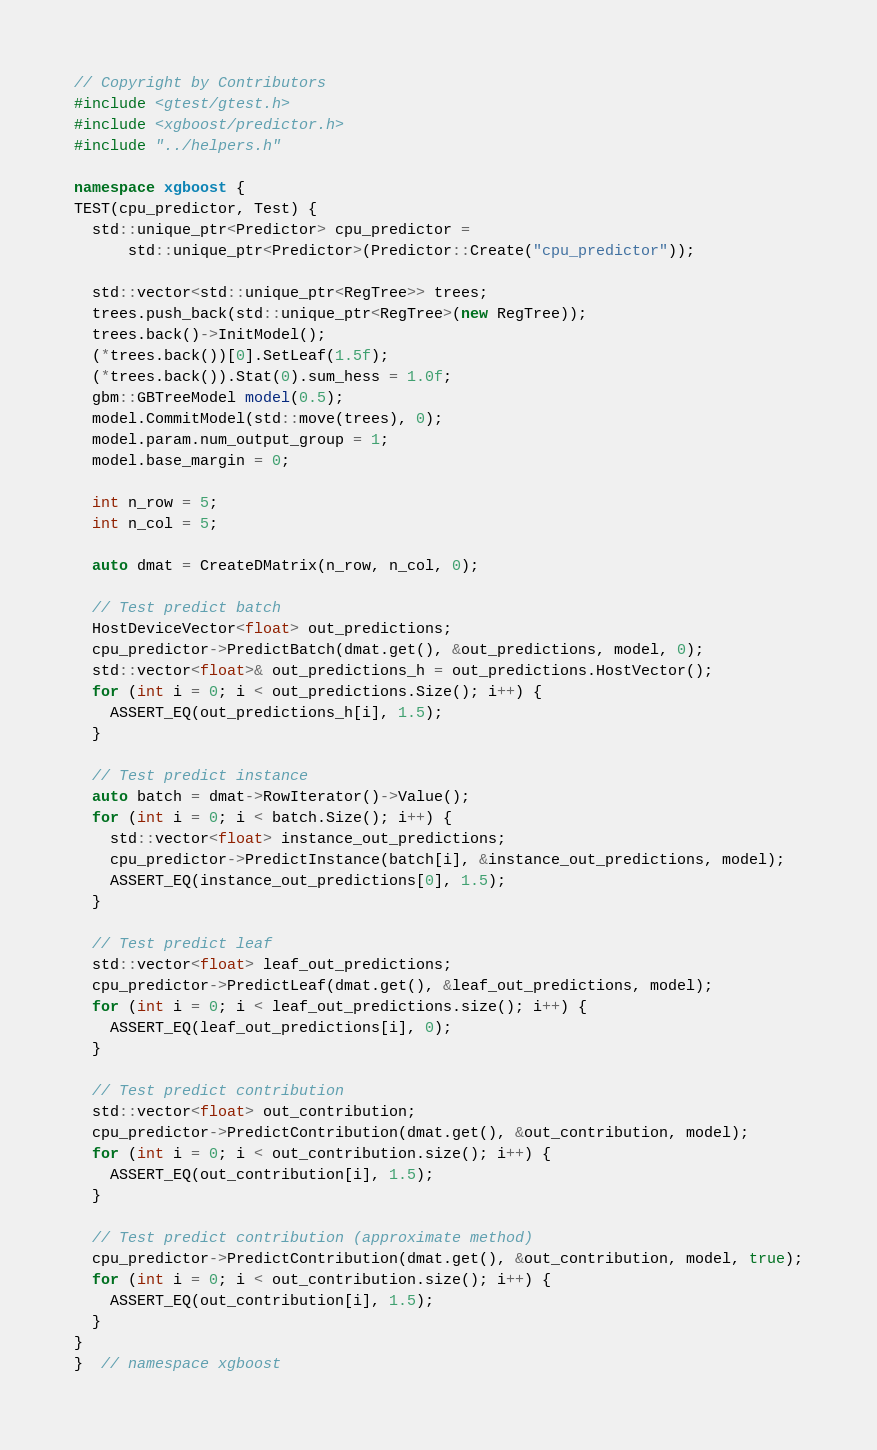<code> <loc_0><loc_0><loc_500><loc_500><_C++_>// Copyright by Contributors
#include <gtest/gtest.h>
#include <xgboost/predictor.h>
#include "../helpers.h"

namespace xgboost {
TEST(cpu_predictor, Test) {
  std::unique_ptr<Predictor> cpu_predictor =
      std::unique_ptr<Predictor>(Predictor::Create("cpu_predictor"));

  std::vector<std::unique_ptr<RegTree>> trees;
  trees.push_back(std::unique_ptr<RegTree>(new RegTree));
  trees.back()->InitModel();
  (*trees.back())[0].SetLeaf(1.5f);
  (*trees.back()).Stat(0).sum_hess = 1.0f;
  gbm::GBTreeModel model(0.5);
  model.CommitModel(std::move(trees), 0);
  model.param.num_output_group = 1;
  model.base_margin = 0;

  int n_row = 5;
  int n_col = 5;

  auto dmat = CreateDMatrix(n_row, n_col, 0);

  // Test predict batch
  HostDeviceVector<float> out_predictions;
  cpu_predictor->PredictBatch(dmat.get(), &out_predictions, model, 0);
  std::vector<float>& out_predictions_h = out_predictions.HostVector();
  for (int i = 0; i < out_predictions.Size(); i++) {
    ASSERT_EQ(out_predictions_h[i], 1.5);
  }

  // Test predict instance
  auto batch = dmat->RowIterator()->Value();
  for (int i = 0; i < batch.Size(); i++) {
    std::vector<float> instance_out_predictions;
    cpu_predictor->PredictInstance(batch[i], &instance_out_predictions, model);
    ASSERT_EQ(instance_out_predictions[0], 1.5);
  }

  // Test predict leaf
  std::vector<float> leaf_out_predictions;
  cpu_predictor->PredictLeaf(dmat.get(), &leaf_out_predictions, model);
  for (int i = 0; i < leaf_out_predictions.size(); i++) {
    ASSERT_EQ(leaf_out_predictions[i], 0);
  }

  // Test predict contribution
  std::vector<float> out_contribution;
  cpu_predictor->PredictContribution(dmat.get(), &out_contribution, model);
  for (int i = 0; i < out_contribution.size(); i++) {
    ASSERT_EQ(out_contribution[i], 1.5);
  }

  // Test predict contribution (approximate method)
  cpu_predictor->PredictContribution(dmat.get(), &out_contribution, model, true);
  for (int i = 0; i < out_contribution.size(); i++) {
    ASSERT_EQ(out_contribution[i], 1.5);
  }
}
}  // namespace xgboost
</code> 